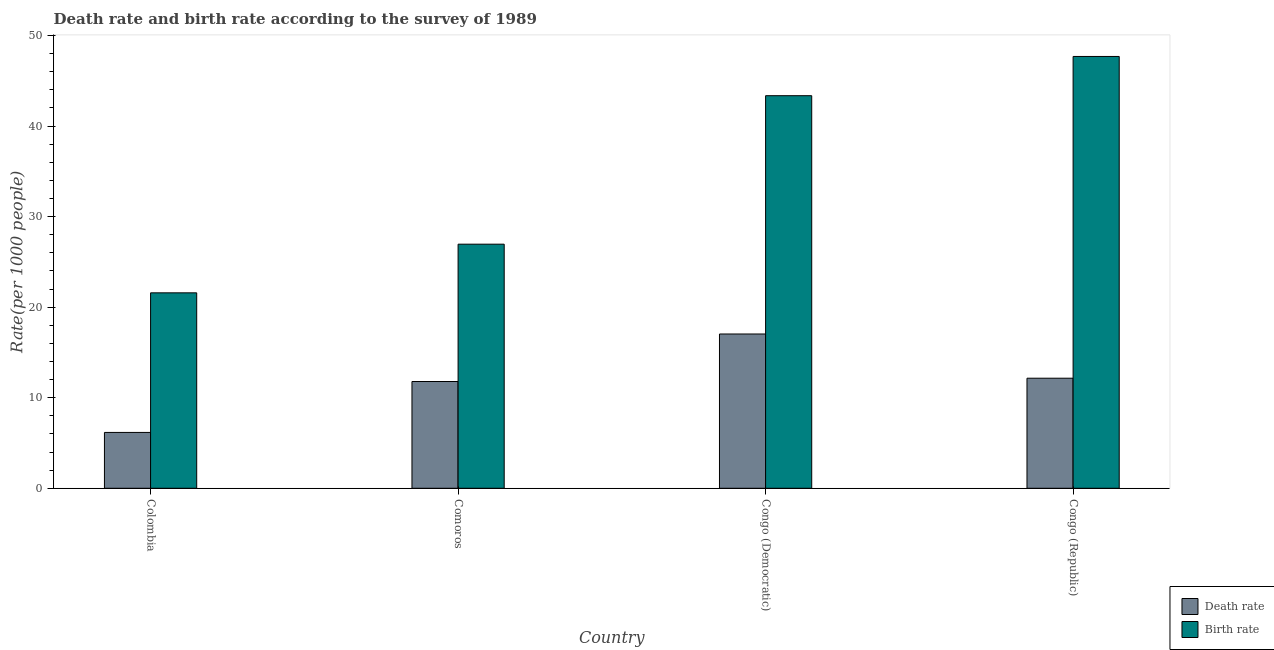How many different coloured bars are there?
Ensure brevity in your answer.  2. How many groups of bars are there?
Keep it short and to the point. 4. Are the number of bars per tick equal to the number of legend labels?
Your response must be concise. Yes. What is the label of the 4th group of bars from the left?
Your answer should be very brief. Congo (Republic). In how many cases, is the number of bars for a given country not equal to the number of legend labels?
Your answer should be compact. 0. What is the birth rate in Congo (Democratic)?
Your answer should be compact. 43.35. Across all countries, what is the maximum death rate?
Your response must be concise. 17.04. Across all countries, what is the minimum death rate?
Keep it short and to the point. 6.17. In which country was the death rate maximum?
Keep it short and to the point. Congo (Democratic). In which country was the birth rate minimum?
Offer a terse response. Colombia. What is the total death rate in the graph?
Offer a terse response. 47.15. What is the difference between the birth rate in Congo (Democratic) and that in Congo (Republic)?
Your response must be concise. -4.33. What is the difference between the death rate in Colombia and the birth rate in Congo (Democratic)?
Ensure brevity in your answer.  -37.18. What is the average death rate per country?
Keep it short and to the point. 11.79. What is the difference between the birth rate and death rate in Congo (Democratic)?
Ensure brevity in your answer.  26.31. What is the ratio of the death rate in Comoros to that in Congo (Democratic)?
Provide a short and direct response. 0.69. Is the difference between the death rate in Congo (Democratic) and Congo (Republic) greater than the difference between the birth rate in Congo (Democratic) and Congo (Republic)?
Your response must be concise. Yes. What is the difference between the highest and the second highest death rate?
Your response must be concise. 4.88. What is the difference between the highest and the lowest birth rate?
Make the answer very short. 26.1. What does the 1st bar from the left in Colombia represents?
Ensure brevity in your answer.  Death rate. What does the 1st bar from the right in Colombia represents?
Offer a terse response. Birth rate. Are all the bars in the graph horizontal?
Provide a short and direct response. No. Where does the legend appear in the graph?
Make the answer very short. Bottom right. How are the legend labels stacked?
Ensure brevity in your answer.  Vertical. What is the title of the graph?
Offer a very short reply. Death rate and birth rate according to the survey of 1989. What is the label or title of the X-axis?
Offer a terse response. Country. What is the label or title of the Y-axis?
Provide a succinct answer. Rate(per 1000 people). What is the Rate(per 1000 people) in Death rate in Colombia?
Provide a succinct answer. 6.17. What is the Rate(per 1000 people) of Birth rate in Colombia?
Provide a succinct answer. 21.58. What is the Rate(per 1000 people) of Death rate in Comoros?
Your answer should be very brief. 11.79. What is the Rate(per 1000 people) of Birth rate in Comoros?
Keep it short and to the point. 26.95. What is the Rate(per 1000 people) in Death rate in Congo (Democratic)?
Your answer should be compact. 17.04. What is the Rate(per 1000 people) of Birth rate in Congo (Democratic)?
Your response must be concise. 43.35. What is the Rate(per 1000 people) of Death rate in Congo (Republic)?
Ensure brevity in your answer.  12.15. What is the Rate(per 1000 people) of Birth rate in Congo (Republic)?
Make the answer very short. 47.68. Across all countries, what is the maximum Rate(per 1000 people) in Death rate?
Make the answer very short. 17.04. Across all countries, what is the maximum Rate(per 1000 people) of Birth rate?
Give a very brief answer. 47.68. Across all countries, what is the minimum Rate(per 1000 people) of Death rate?
Provide a succinct answer. 6.17. Across all countries, what is the minimum Rate(per 1000 people) in Birth rate?
Offer a very short reply. 21.58. What is the total Rate(per 1000 people) in Death rate in the graph?
Provide a succinct answer. 47.15. What is the total Rate(per 1000 people) in Birth rate in the graph?
Make the answer very short. 139.56. What is the difference between the Rate(per 1000 people) in Death rate in Colombia and that in Comoros?
Give a very brief answer. -5.62. What is the difference between the Rate(per 1000 people) of Birth rate in Colombia and that in Comoros?
Provide a succinct answer. -5.37. What is the difference between the Rate(per 1000 people) of Death rate in Colombia and that in Congo (Democratic)?
Offer a terse response. -10.87. What is the difference between the Rate(per 1000 people) in Birth rate in Colombia and that in Congo (Democratic)?
Your answer should be compact. -21.77. What is the difference between the Rate(per 1000 people) in Death rate in Colombia and that in Congo (Republic)?
Keep it short and to the point. -5.99. What is the difference between the Rate(per 1000 people) of Birth rate in Colombia and that in Congo (Republic)?
Your answer should be compact. -26.1. What is the difference between the Rate(per 1000 people) of Death rate in Comoros and that in Congo (Democratic)?
Ensure brevity in your answer.  -5.25. What is the difference between the Rate(per 1000 people) in Birth rate in Comoros and that in Congo (Democratic)?
Offer a very short reply. -16.39. What is the difference between the Rate(per 1000 people) in Death rate in Comoros and that in Congo (Republic)?
Provide a succinct answer. -0.36. What is the difference between the Rate(per 1000 people) in Birth rate in Comoros and that in Congo (Republic)?
Keep it short and to the point. -20.73. What is the difference between the Rate(per 1000 people) of Death rate in Congo (Democratic) and that in Congo (Republic)?
Make the answer very short. 4.88. What is the difference between the Rate(per 1000 people) of Birth rate in Congo (Democratic) and that in Congo (Republic)?
Ensure brevity in your answer.  -4.33. What is the difference between the Rate(per 1000 people) of Death rate in Colombia and the Rate(per 1000 people) of Birth rate in Comoros?
Your response must be concise. -20.79. What is the difference between the Rate(per 1000 people) of Death rate in Colombia and the Rate(per 1000 people) of Birth rate in Congo (Democratic)?
Offer a very short reply. -37.18. What is the difference between the Rate(per 1000 people) in Death rate in Colombia and the Rate(per 1000 people) in Birth rate in Congo (Republic)?
Give a very brief answer. -41.51. What is the difference between the Rate(per 1000 people) in Death rate in Comoros and the Rate(per 1000 people) in Birth rate in Congo (Democratic)?
Provide a succinct answer. -31.56. What is the difference between the Rate(per 1000 people) of Death rate in Comoros and the Rate(per 1000 people) of Birth rate in Congo (Republic)?
Your answer should be compact. -35.89. What is the difference between the Rate(per 1000 people) in Death rate in Congo (Democratic) and the Rate(per 1000 people) in Birth rate in Congo (Republic)?
Offer a very short reply. -30.64. What is the average Rate(per 1000 people) in Death rate per country?
Make the answer very short. 11.79. What is the average Rate(per 1000 people) in Birth rate per country?
Ensure brevity in your answer.  34.89. What is the difference between the Rate(per 1000 people) of Death rate and Rate(per 1000 people) of Birth rate in Colombia?
Your answer should be compact. -15.41. What is the difference between the Rate(per 1000 people) of Death rate and Rate(per 1000 people) of Birth rate in Comoros?
Provide a succinct answer. -15.16. What is the difference between the Rate(per 1000 people) in Death rate and Rate(per 1000 people) in Birth rate in Congo (Democratic)?
Offer a terse response. -26.31. What is the difference between the Rate(per 1000 people) of Death rate and Rate(per 1000 people) of Birth rate in Congo (Republic)?
Keep it short and to the point. -35.52. What is the ratio of the Rate(per 1000 people) of Death rate in Colombia to that in Comoros?
Provide a short and direct response. 0.52. What is the ratio of the Rate(per 1000 people) of Birth rate in Colombia to that in Comoros?
Provide a short and direct response. 0.8. What is the ratio of the Rate(per 1000 people) in Death rate in Colombia to that in Congo (Democratic)?
Give a very brief answer. 0.36. What is the ratio of the Rate(per 1000 people) of Birth rate in Colombia to that in Congo (Democratic)?
Your answer should be very brief. 0.5. What is the ratio of the Rate(per 1000 people) of Death rate in Colombia to that in Congo (Republic)?
Offer a terse response. 0.51. What is the ratio of the Rate(per 1000 people) of Birth rate in Colombia to that in Congo (Republic)?
Your answer should be compact. 0.45. What is the ratio of the Rate(per 1000 people) of Death rate in Comoros to that in Congo (Democratic)?
Make the answer very short. 0.69. What is the ratio of the Rate(per 1000 people) of Birth rate in Comoros to that in Congo (Democratic)?
Give a very brief answer. 0.62. What is the ratio of the Rate(per 1000 people) in Death rate in Comoros to that in Congo (Republic)?
Offer a very short reply. 0.97. What is the ratio of the Rate(per 1000 people) in Birth rate in Comoros to that in Congo (Republic)?
Your answer should be very brief. 0.57. What is the ratio of the Rate(per 1000 people) in Death rate in Congo (Democratic) to that in Congo (Republic)?
Provide a short and direct response. 1.4. What is the difference between the highest and the second highest Rate(per 1000 people) of Death rate?
Your answer should be compact. 4.88. What is the difference between the highest and the second highest Rate(per 1000 people) in Birth rate?
Offer a terse response. 4.33. What is the difference between the highest and the lowest Rate(per 1000 people) of Death rate?
Give a very brief answer. 10.87. What is the difference between the highest and the lowest Rate(per 1000 people) in Birth rate?
Your answer should be compact. 26.1. 